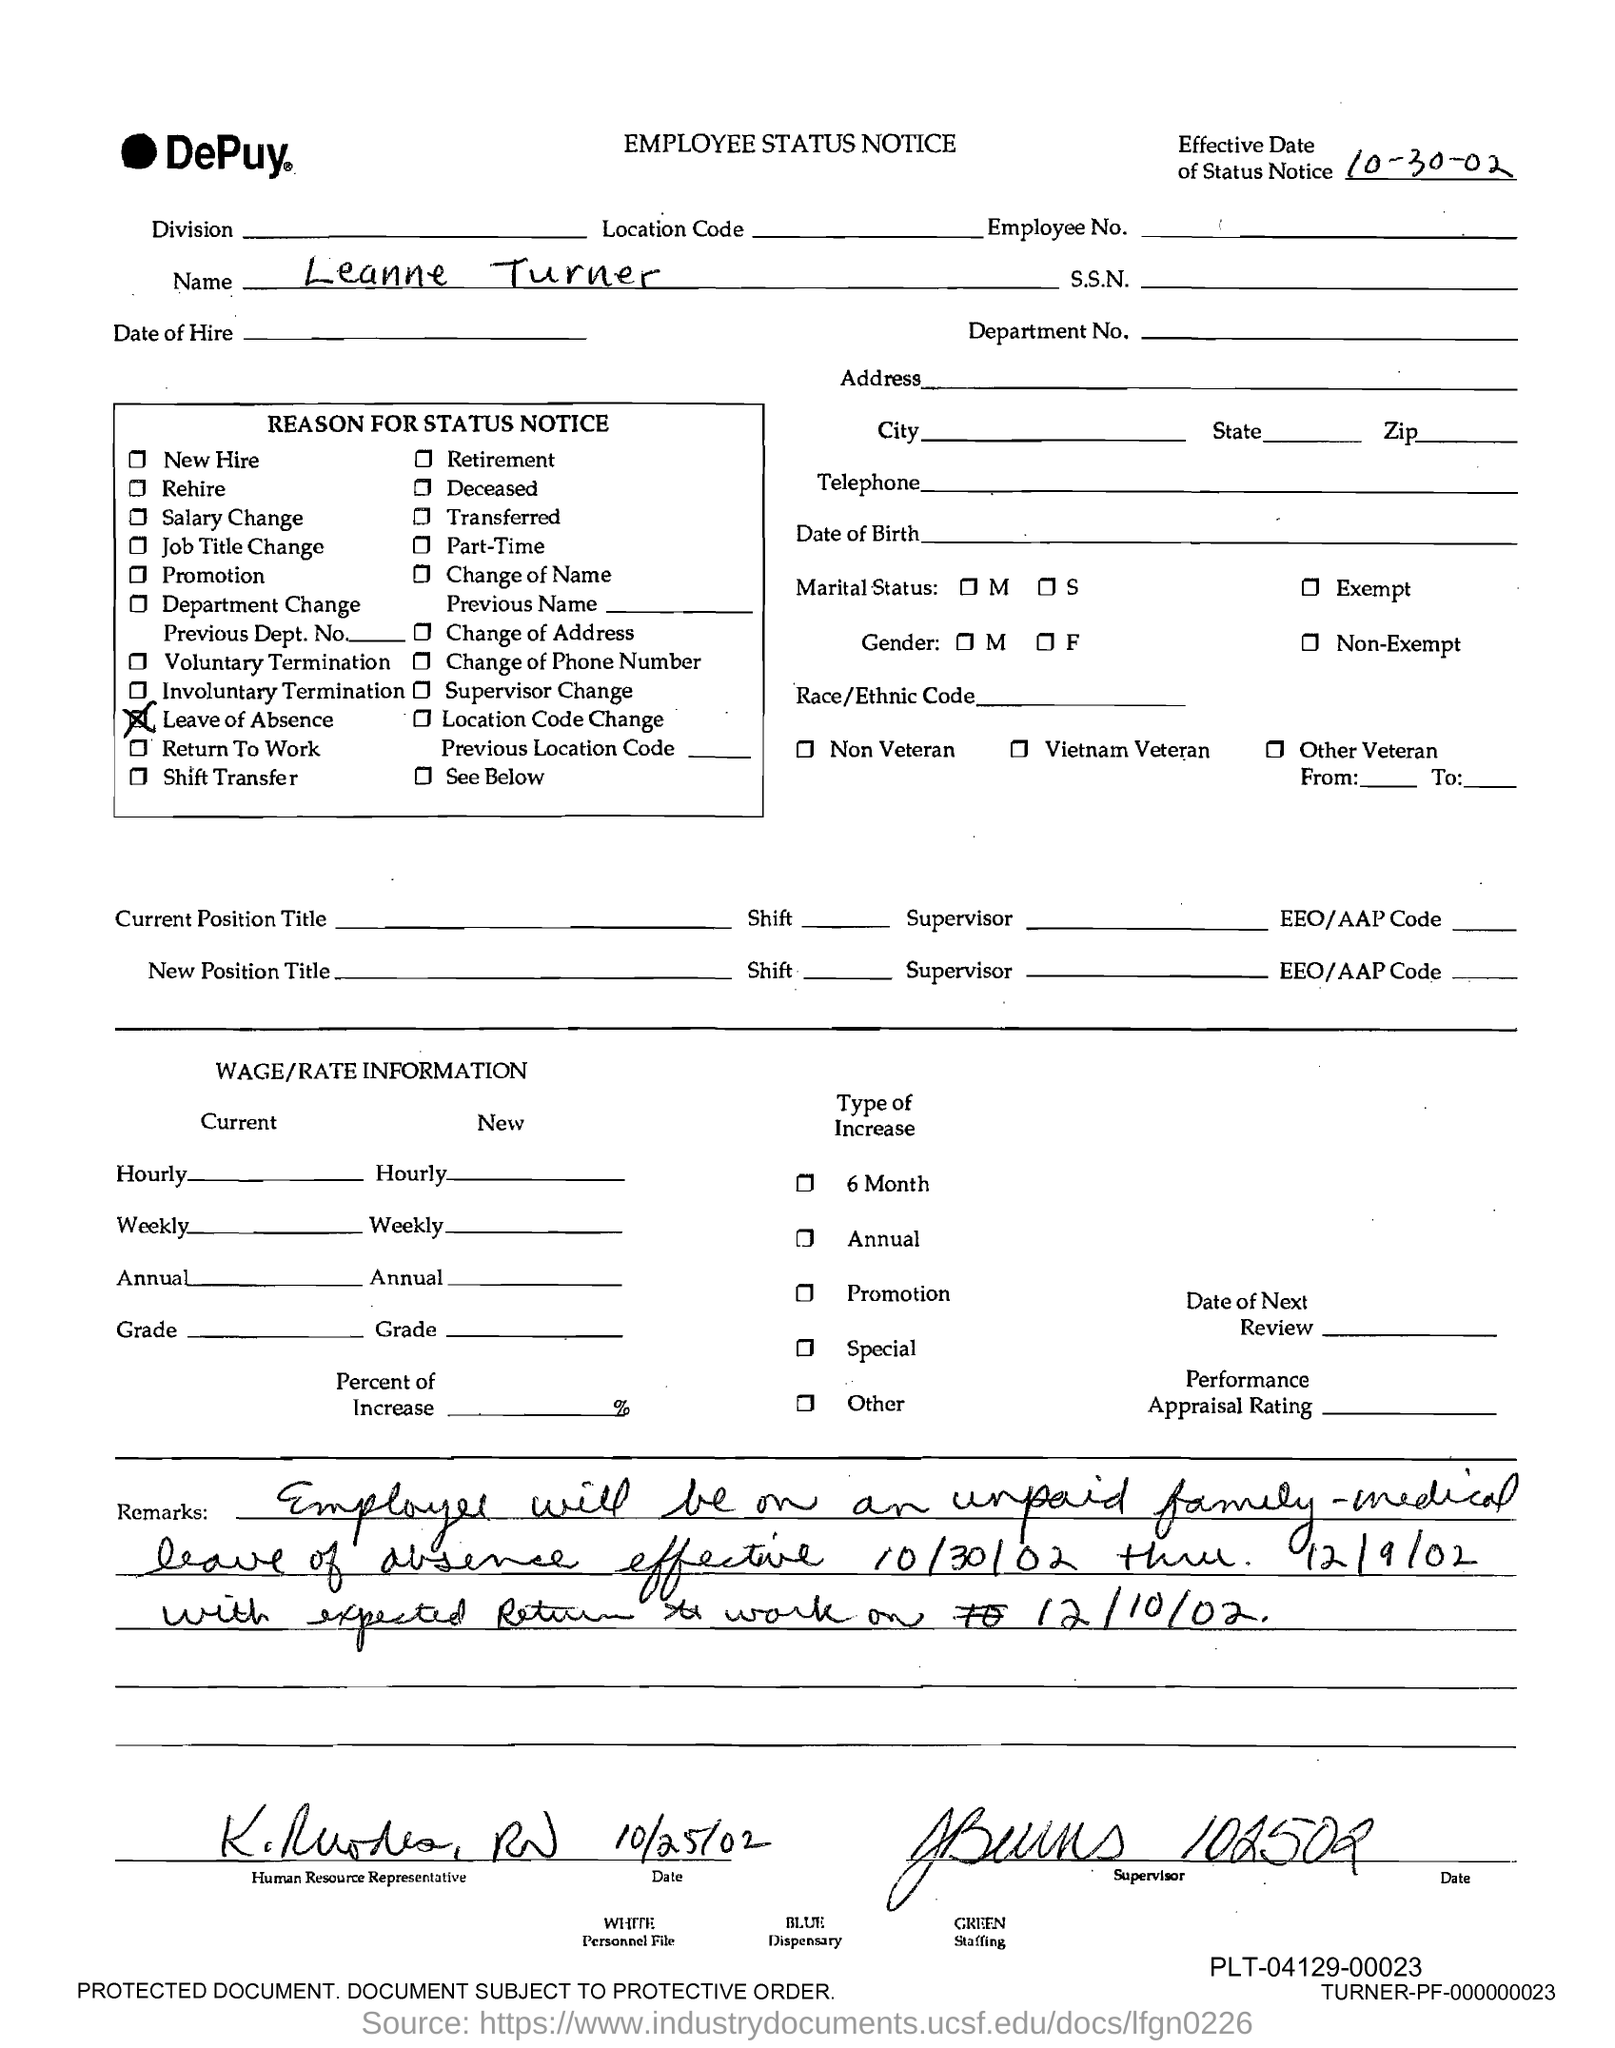What is the effective date of status notice?
Provide a short and direct response. 10-30-02. What is the name given in the employee status notice?
Your response must be concise. Leanne Turner. What is the reason for status notice?
Your answer should be very brief. Leave of Absence. Which company's employee status notice is this?
Keep it short and to the point. DePuy. 